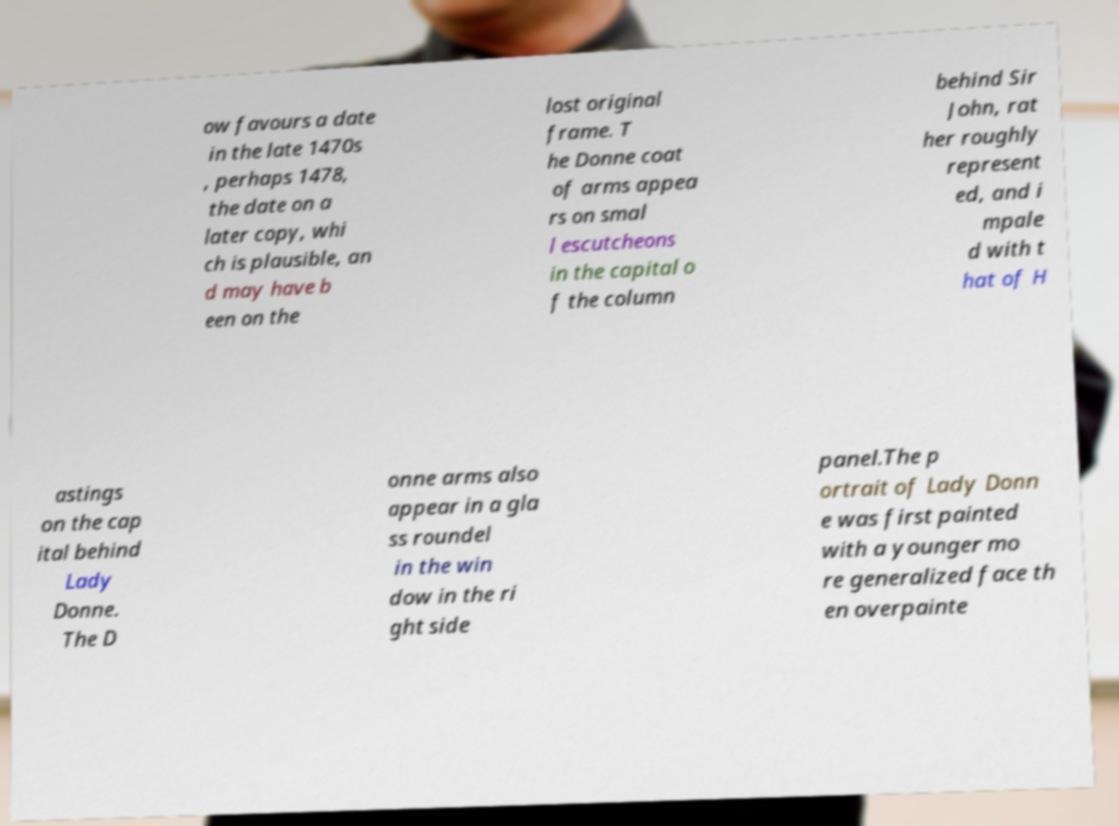For documentation purposes, I need the text within this image transcribed. Could you provide that? ow favours a date in the late 1470s , perhaps 1478, the date on a later copy, whi ch is plausible, an d may have b een on the lost original frame. T he Donne coat of arms appea rs on smal l escutcheons in the capital o f the column behind Sir John, rat her roughly represent ed, and i mpale d with t hat of H astings on the cap ital behind Lady Donne. The D onne arms also appear in a gla ss roundel in the win dow in the ri ght side panel.The p ortrait of Lady Donn e was first painted with a younger mo re generalized face th en overpainte 